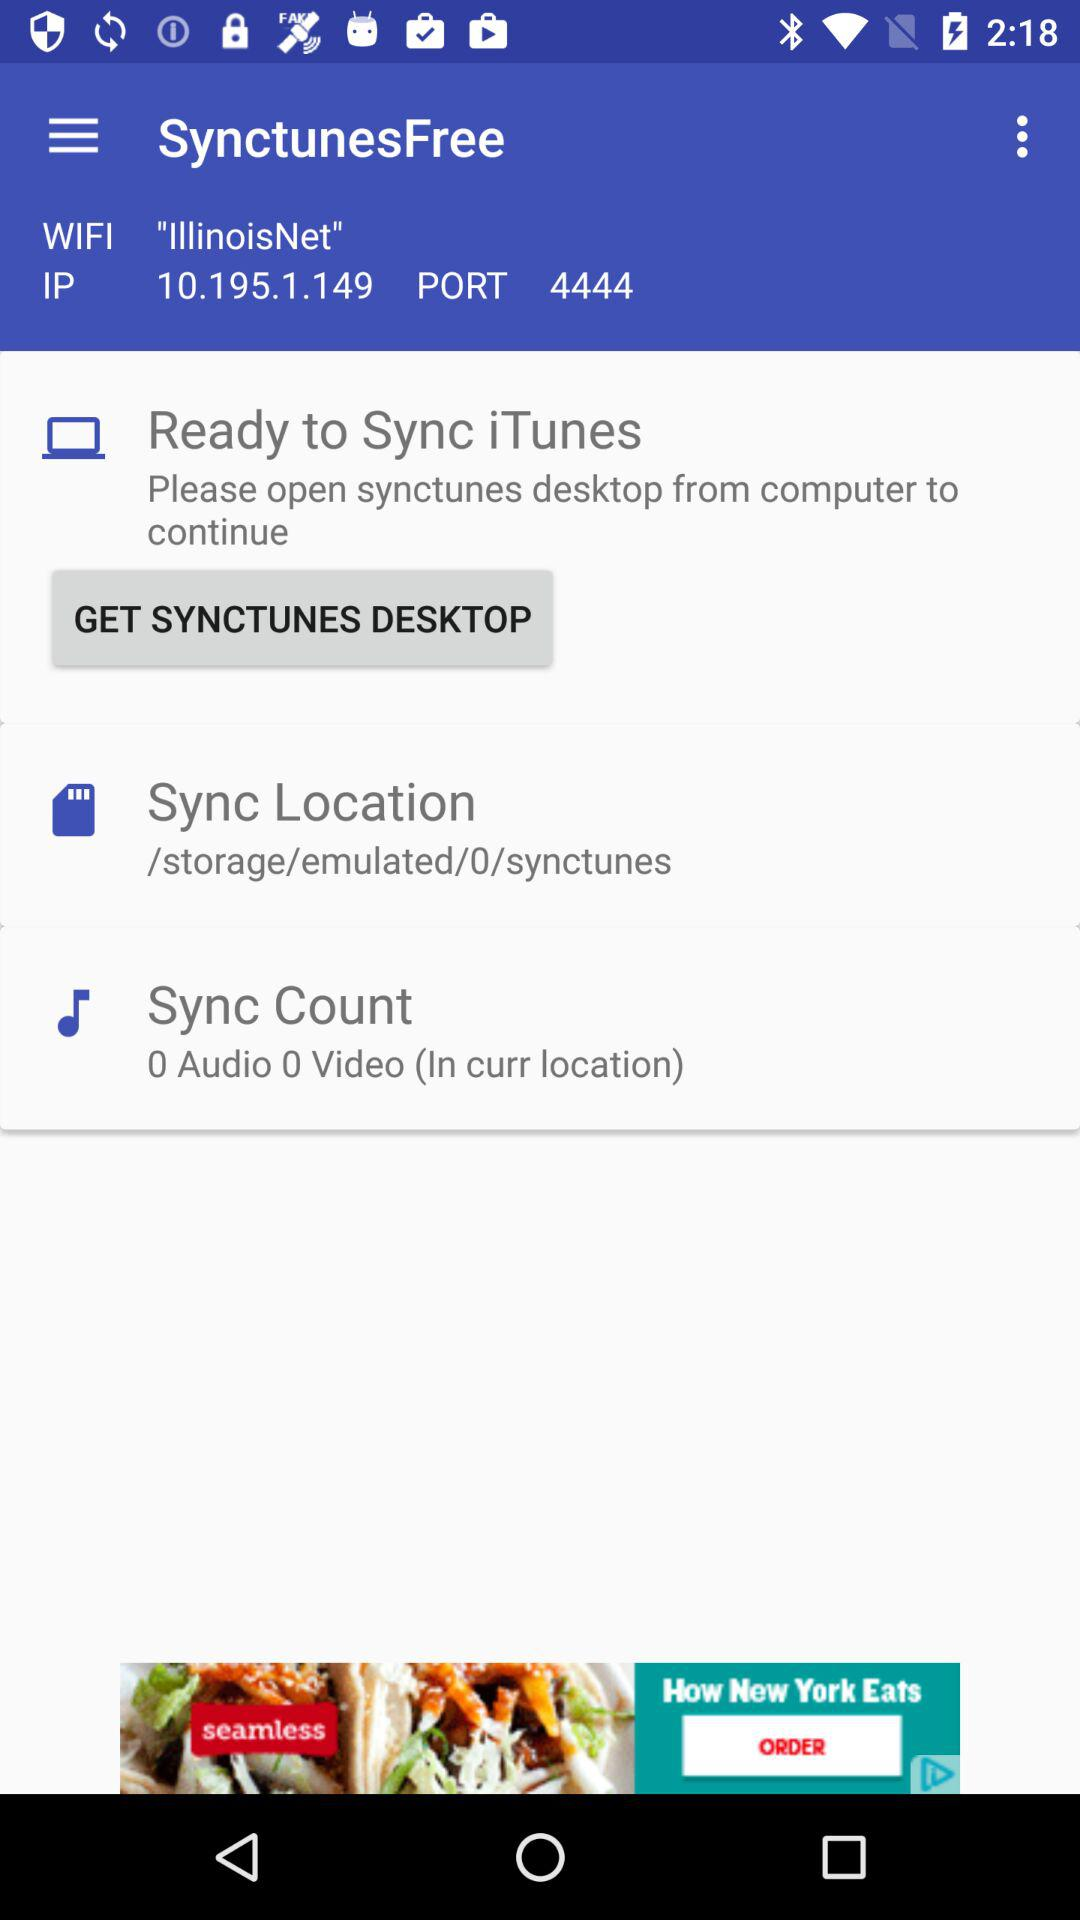How many audio files are there in the current location?
Answer the question using a single word or phrase. 0 